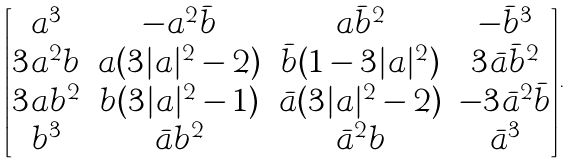Convert formula to latex. <formula><loc_0><loc_0><loc_500><loc_500>\begin{bmatrix} a ^ { 3 } & - a ^ { 2 } \bar { b } & a \bar { b } ^ { 2 } & - \bar { b } ^ { 3 } \\ 3 a ^ { 2 } b & a ( 3 | a | ^ { 2 } - 2 ) & \bar { b } ( 1 - 3 | a | ^ { 2 } ) & 3 \bar { a } \bar { b } ^ { 2 } \\ 3 a b ^ { 2 } & b ( 3 | a | ^ { 2 } - 1 ) & \bar { a } ( 3 | a | ^ { 2 } - 2 ) & - 3 \bar { a } ^ { 2 } \bar { b } \\ b ^ { 3 } & \bar { a } b ^ { 2 } & \bar { a } ^ { 2 } b & \bar { a } ^ { 3 } \end{bmatrix} .</formula> 